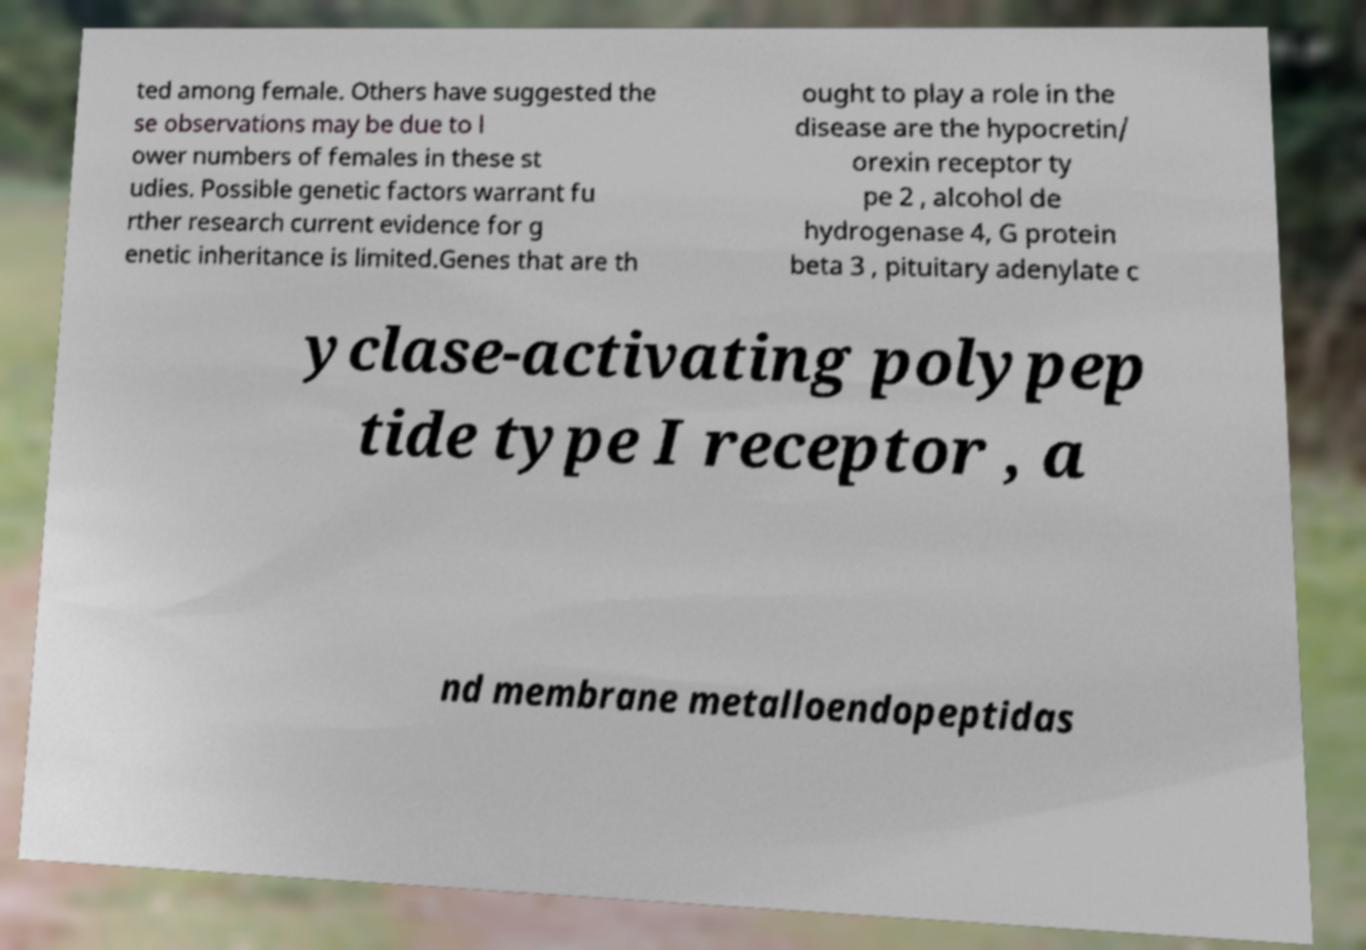There's text embedded in this image that I need extracted. Can you transcribe it verbatim? ted among female. Others have suggested the se observations may be due to l ower numbers of females in these st udies. Possible genetic factors warrant fu rther research current evidence for g enetic inheritance is limited.Genes that are th ought to play a role in the disease are the hypocretin/ orexin receptor ty pe 2 , alcohol de hydrogenase 4, G protein beta 3 , pituitary adenylate c yclase-activating polypep tide type I receptor , a nd membrane metalloendopeptidas 